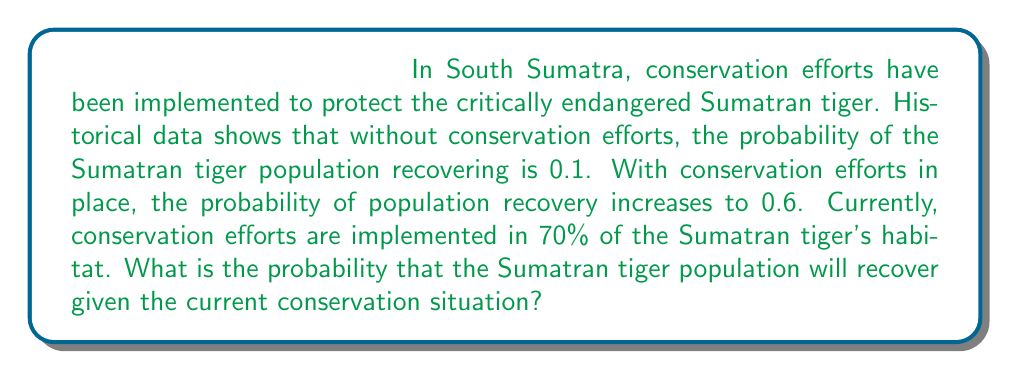Provide a solution to this math problem. To solve this problem, we can use Bayes' theorem and the law of total probability. Let's define our events:

$R$: Sumatran tiger population recovers
$C$: Conservation efforts are implemented

Given:
$P(R|C) = 0.6$ (probability of recovery given conservation efforts)
$P(R|\neg C) = 0.1$ (probability of recovery without conservation efforts)
$P(C) = 0.7$ (probability of conservation efforts being implemented)

We want to find $P(R)$, the probability of recovery given the current situation.

Using the law of total probability:

$$P(R) = P(R|C) \cdot P(C) + P(R|\neg C) \cdot P(\neg C)$$

First, calculate $P(\neg C)$:
$P(\neg C) = 1 - P(C) = 1 - 0.7 = 0.3$

Now, we can plug in the values:

$$\begin{align}
P(R) &= P(R|C) \cdot P(C) + P(R|\neg C) \cdot P(\neg C) \\
&= 0.6 \cdot 0.7 + 0.1 \cdot 0.3 \\
&= 0.42 + 0.03 \\
&= 0.45
\end{align}$$

Therefore, the probability that the Sumatran tiger population will recover given the current conservation situation is 0.45 or 45%.
Answer: 0.45 or 45% 